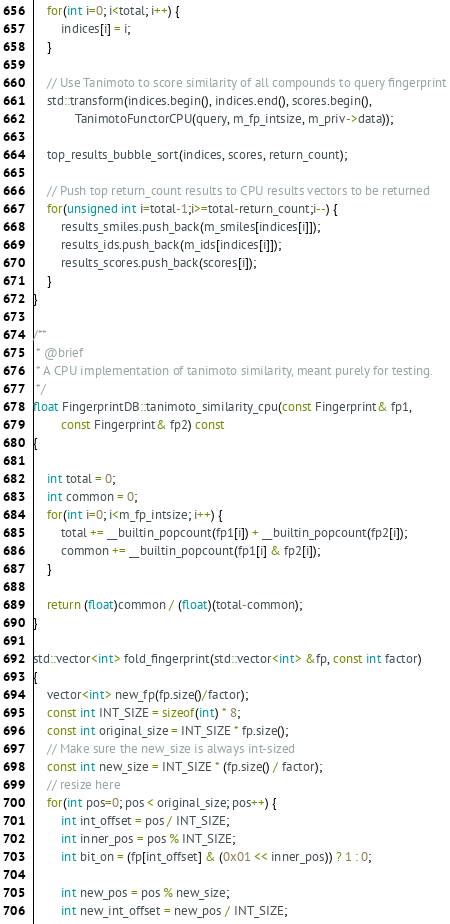Convert code to text. <code><loc_0><loc_0><loc_500><loc_500><_Cuda_>    for(int i=0; i<total; i++) {
        indices[i] = i;
    }

    // Use Tanimoto to score similarity of all compounds to query fingerprint
    std::transform(indices.begin(), indices.end(), scores.begin(),
            TanimotoFunctorCPU(query, m_fp_intsize, m_priv->data));

    top_results_bubble_sort(indices, scores, return_count);

    // Push top return_count results to CPU results vectors to be returned
    for(unsigned int i=total-1;i>=total-return_count;i--) {
        results_smiles.push_back(m_smiles[indices[i]]);
        results_ids.push_back(m_ids[indices[i]]);
        results_scores.push_back(scores[i]);
    }
}

/**
 * @brief
 * A CPU implementation of tanimoto similarity, meant purely for testing.
 */
float FingerprintDB::tanimoto_similarity_cpu(const Fingerprint& fp1,
        const Fingerprint& fp2) const
{

    int total = 0;
    int common = 0;
    for(int i=0; i<m_fp_intsize; i++) {
        total += __builtin_popcount(fp1[i]) + __builtin_popcount(fp2[i]); 
        common += __builtin_popcount(fp1[i] & fp2[i]);
    }

    return (float)common / (float)(total-common);
}

std::vector<int> fold_fingerprint(std::vector<int> &fp, const int factor)
{
    vector<int> new_fp(fp.size()/factor);
    const int INT_SIZE = sizeof(int) * 8;
    const int original_size = INT_SIZE * fp.size();
    // Make sure the new_size is always int-sized
    const int new_size = INT_SIZE * (fp.size() / factor);
    // resize here
    for(int pos=0; pos < original_size; pos++) {
        int int_offset = pos / INT_SIZE;
        int inner_pos = pos % INT_SIZE;
        int bit_on = (fp[int_offset] & (0x01 << inner_pos)) ? 1 : 0;

        int new_pos = pos % new_size;
        int new_int_offset = new_pos / INT_SIZE;</code> 